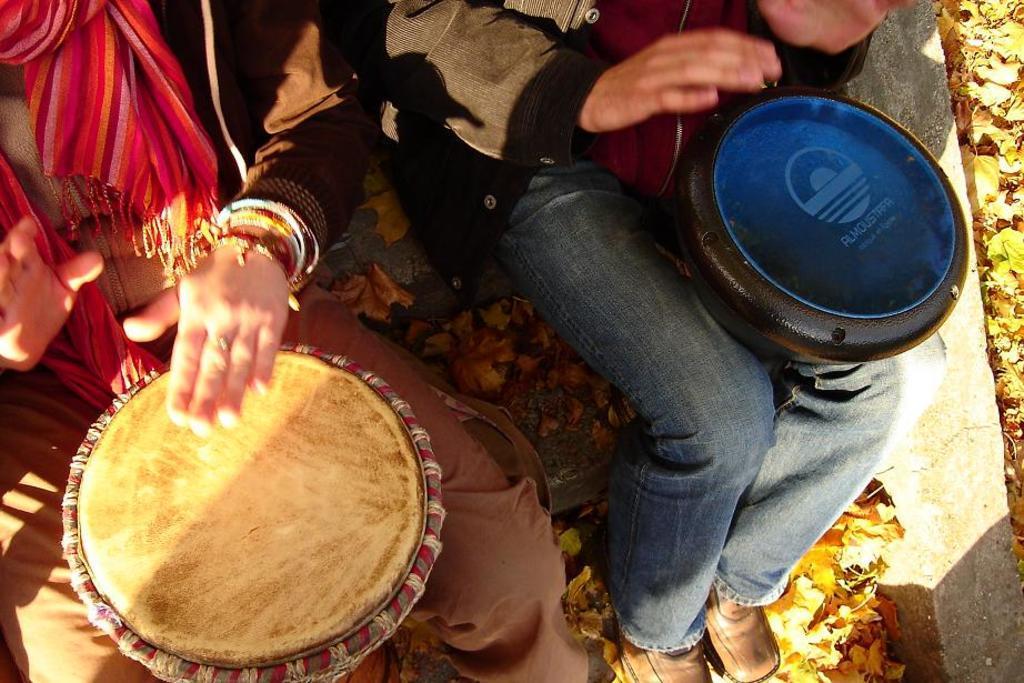How would you summarize this image in a sentence or two? In the image we can see there are persons who are sitting and there is a drum in between their lap. 